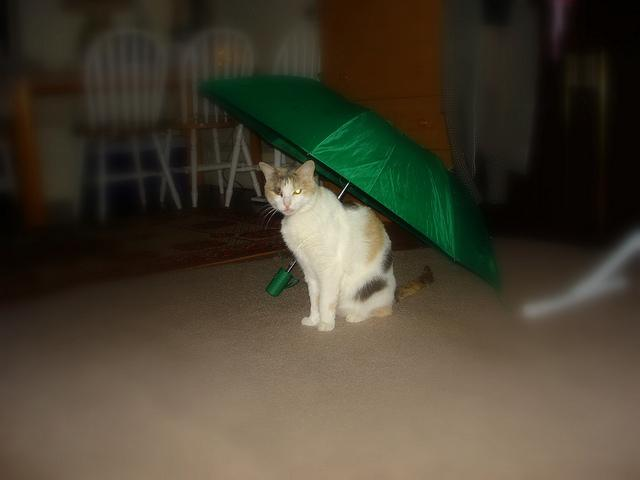What is the white object to the right of the cat likely to be? Please explain your reasoning. ironing board. The object is for ironing. 